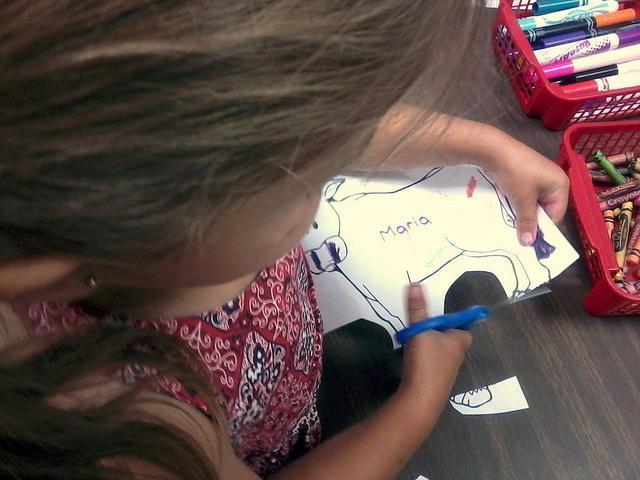How many cars only have one headlight?
Give a very brief answer. 0. 